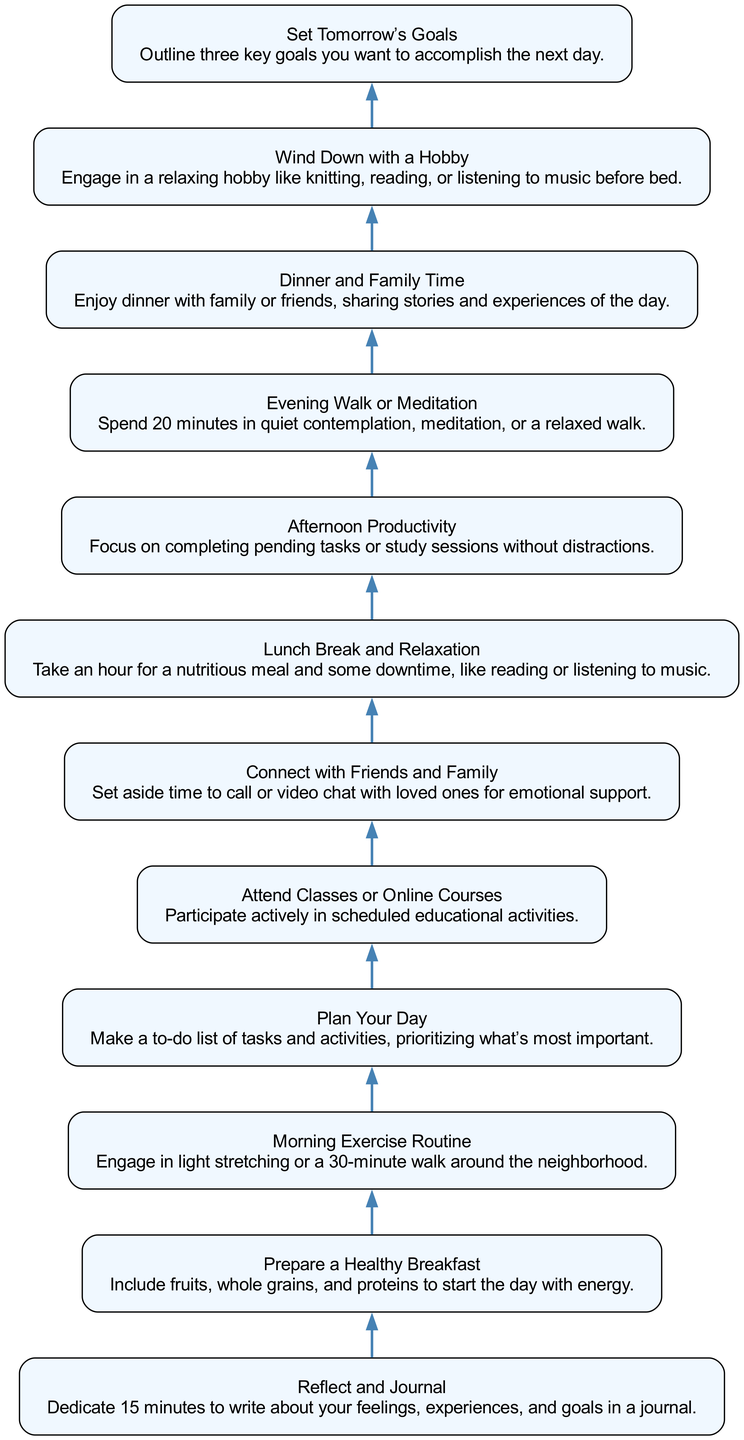What is the first step in the daily routine? The first step in the routine, as seen at the bottom of the flow chart, is "Reflect and Journal," where one dedicates 15 minutes to write about their feelings, experiences, and goals.
Answer: Reflect and Journal How many steps are there in total? Counting all the nodes in the flow chart, there are 12 steps listed, starting from "Reflect and Journal" at the bottom and ending with "Set Tomorrow's Goals" at the top.
Answer: 12 What is the last step in the daily routine? The last step at the top of the flow chart is "Set Tomorrow's Goals," where one outlines three key goals to accomplish the next day.
Answer: Set Tomorrow’s Goals Which step involves family time? In the flow chart, the step that includes family time is "Dinner and Family Time," where one enjoys dinner with loved ones and shares experiences.
Answer: Dinner and Family Time Which two steps focus on social connections? "Connect with Friends and Family" and "Dinner and Family Time" are the two steps that emphasize maintaining social connections with loved ones.
Answer: Connect with Friends and Family; Dinner and Family Time What activity is suggested after "Afternoon Productivity"? Following "Afternoon Productivity," the next step is "Evening Walk or Meditation," which suggests spending time in quiet contemplation or a relaxed walk.
Answer: Evening Walk or Meditation How does the routine begin? The routine begins with "Reflect and Journal," indicating that one should take time at the start of the day for reflection and journaling.
Answer: Reflect and Journal What is the purpose of "Plan Your Day"? The purpose of "Plan Your Day" is to create a prioritized to-do list of tasks and activities that are most important for the day.
Answer: Make a to-do list of tasks and activities What is the time allocated for "Lunch Break and Relaxation"? The time allocated for "Lunch Break and Relaxation" is one hour, providing space for a nutritious meal and some downtime.
Answer: One hour What type of activity precedes "Wind Down with a Hobby"? The activity before "Wind Down with a Hobby" is "Dinner and Family Time," suggesting that one should enjoy dinner and engage with family before relaxing with a hobby.
Answer: Dinner and Family Time 